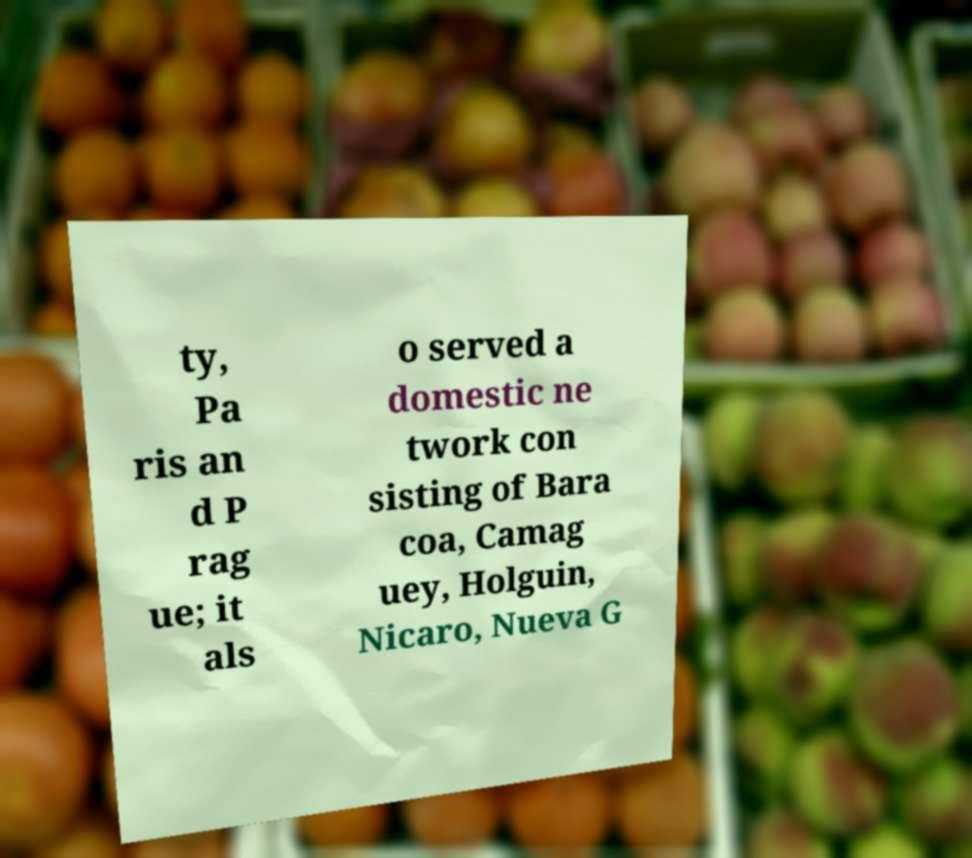I need the written content from this picture converted into text. Can you do that? ty, Pa ris an d P rag ue; it als o served a domestic ne twork con sisting of Bara coa, Camag uey, Holguin, Nicaro, Nueva G 